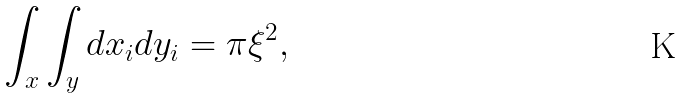Convert formula to latex. <formula><loc_0><loc_0><loc_500><loc_500>\int _ { x } \int _ { y } d x _ { i } d y _ { i } = \pi \xi ^ { 2 } ,</formula> 